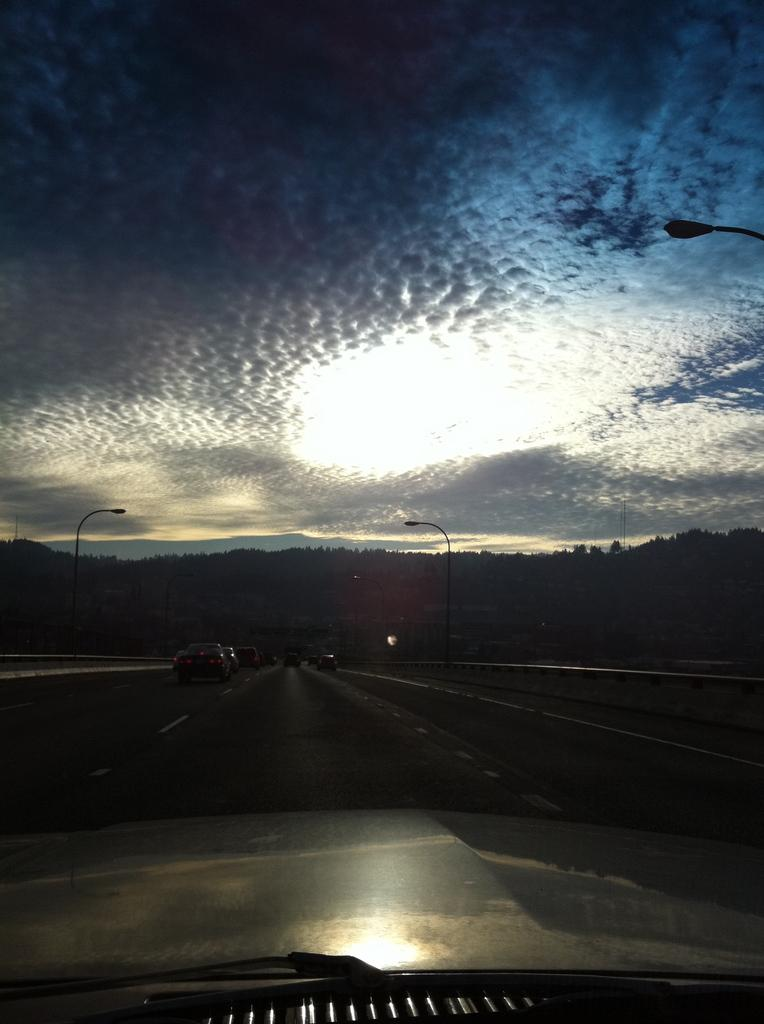What is the main subject in the foreground of the image? There is a car in the foreground of the image. What other vehicles can be seen in the image? There are vehicles in the image. What objects are present in the image besides vehicles? There are poles in the image. What can be seen in the background of the image? There are trees and the sky visible in the background of the image. What type of stamp can be seen on the car's windshield in the image? There is no stamp visible on the car's windshield in the image. How does the throat of the car appear in the image? Cars do not have throats, so this question is not applicable to the image. 